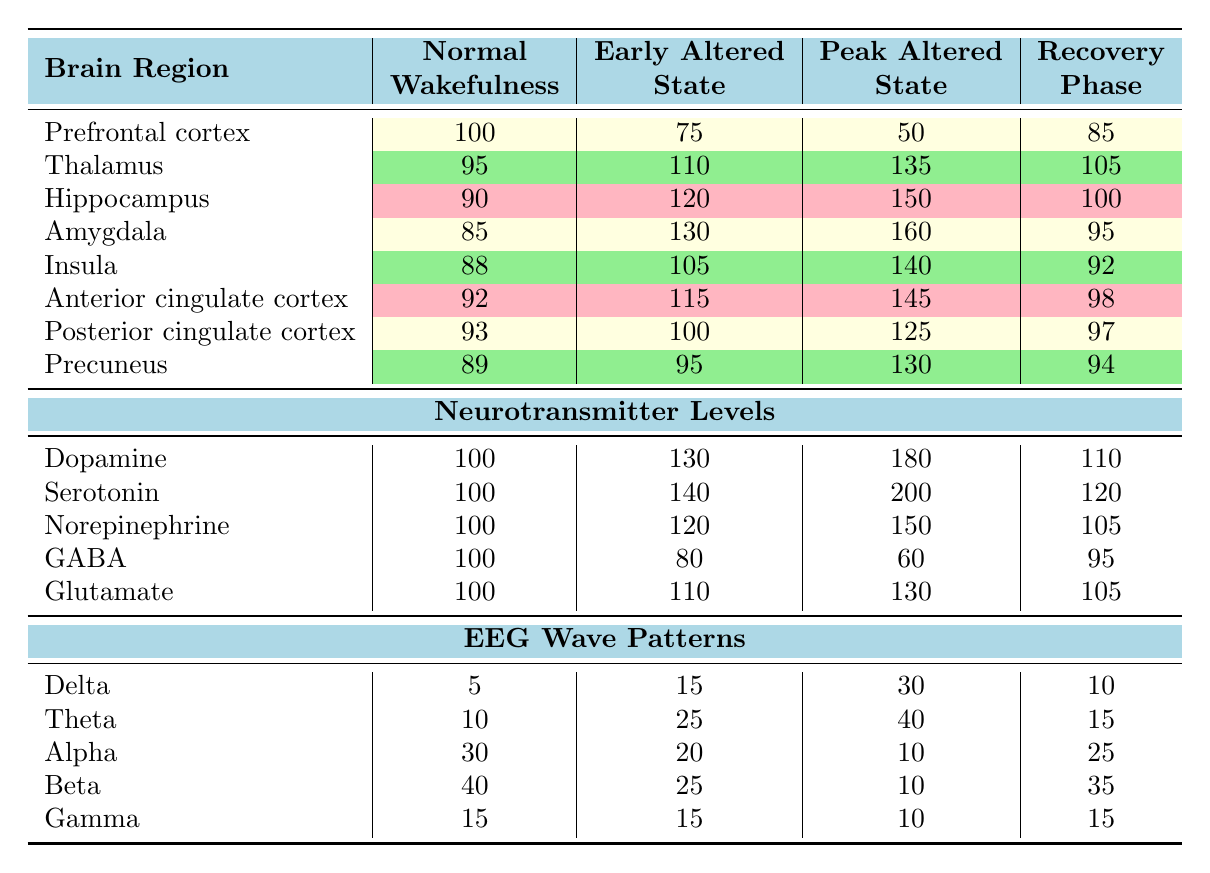What is the activity level in the Hippocampus during the Peak altered state? The table shows that the activity level in the Hippocampus during the Peak altered state is 150.
Answer: 150 Which brain region shows the highest activity level in the Early altered state? In the Early altered state, the Amygdala has the highest activity level at 130, compared to other regions listed.
Answer: Amygdala What is the difference in activity levels of the Thalamus between the Peak altered state and the Recovery phase? The Thalamus level is 135 during the Peak altered state and 105 during the Recovery phase. The difference is 135 - 105 = 30.
Answer: 30 Is the activity level of the Prefrontal cortex higher in the Normal wakefulness or the Recovery phase? The activity level in the Prefrontal cortex is 100 during Normal wakefulness and 85 during the Recovery phase, hence it is higher in Normal wakefulness.
Answer: Yes Calculate the average activity level of the Insula across all consciousness phases. The activity levels of the Insula are 88 (Normal wakefulness), 105 (Early altered state), 140 (Peak altered state), and 92 (Recovery phase). Adding these gives 88 + 105 + 140 + 92 = 425. Dividing by the number of phases (4) results in an average of 425/4 = 106.25.
Answer: 106.25 What is the neurotransmitter level of Serotonin during the Peak altered state? The table indicates that the neurotransmitter level of Serotonin during the Peak altered state is 200.
Answer: 200 Which EEG wave pattern shows the highest level in the Normal wakefulness phase? In the Normal wakefulness phase, the highest EEG wave pattern level is in the Beta category, with a value of 40.
Answer: Beta What is the total neurotransmitter level of all measured neurotransmitters during the Early altered state? The neurotransmitter values during the Early altered state are: Dopamine (130), Serotonin (140), Norepinephrine (120), GABA (80), Glutamate (110). Adding these gives 130 + 140 + 120 + 80 + 110 = 680.
Answer: 680 Is there a decrease in the activity level of the Anterior cingulate cortex from the Early altered state to the Peak altered state? The Anterior cingulate cortex level decreases from 115 in the Early altered state to 145 in the Peak altered state, indicating an increase, not a decrease.
Answer: No Which EEG wave pattern shows the least change from Normal wakefulness to Recovery phase? By comparing the values, Delta shows a change from 5 to 10 (an increase of 5), Theta from 10 to 15 (increase of 5), Alpha from 30 to 25 (a decrease of 5), and Beta from 40 to 35 (a decrease of 5), while Gamma remains constant at 15. Therefore, it has the least change.
Answer: Delta and Gamma 